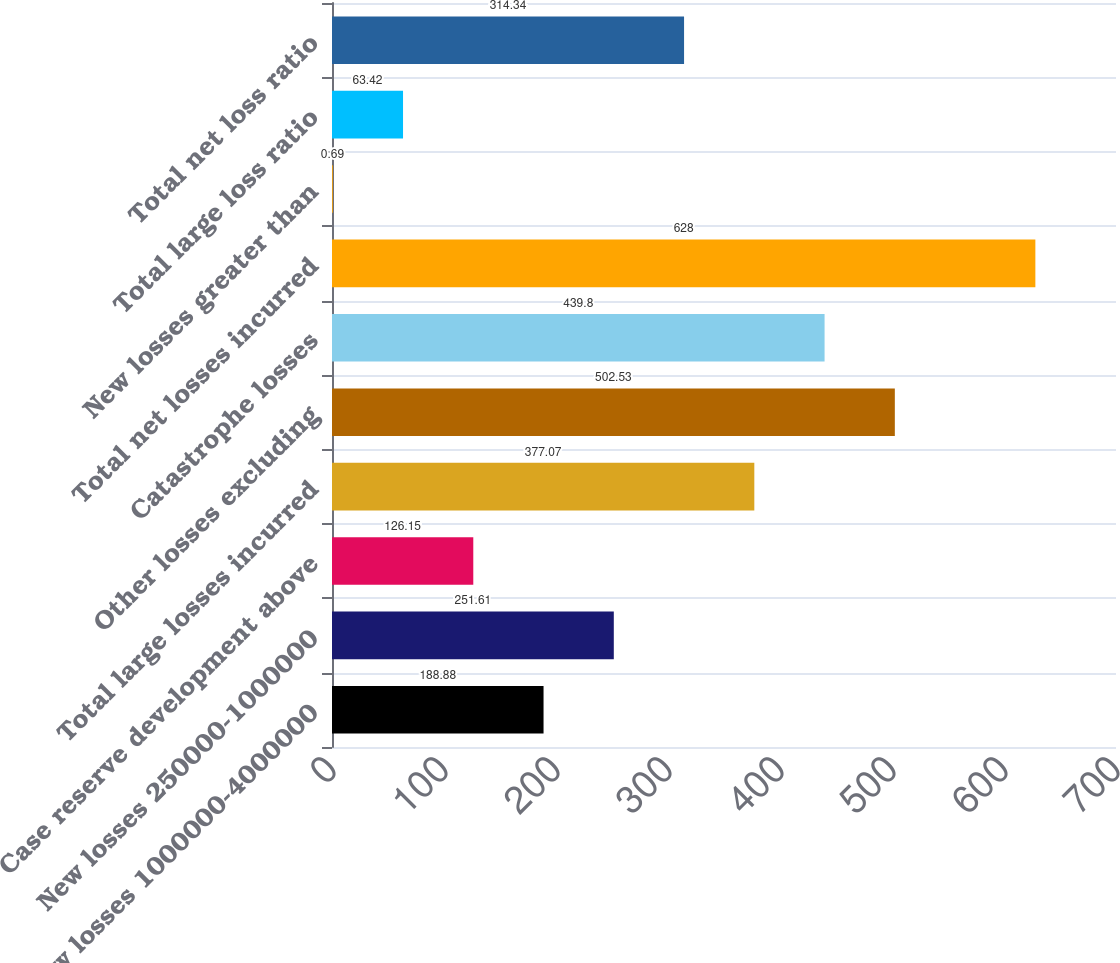<chart> <loc_0><loc_0><loc_500><loc_500><bar_chart><fcel>New losses 1000000-4000000<fcel>New losses 250000-1000000<fcel>Case reserve development above<fcel>Total large losses incurred<fcel>Other losses excluding<fcel>Catastrophe losses<fcel>Total net losses incurred<fcel>New losses greater than<fcel>Total large loss ratio<fcel>Total net loss ratio<nl><fcel>188.88<fcel>251.61<fcel>126.15<fcel>377.07<fcel>502.53<fcel>439.8<fcel>628<fcel>0.69<fcel>63.42<fcel>314.34<nl></chart> 